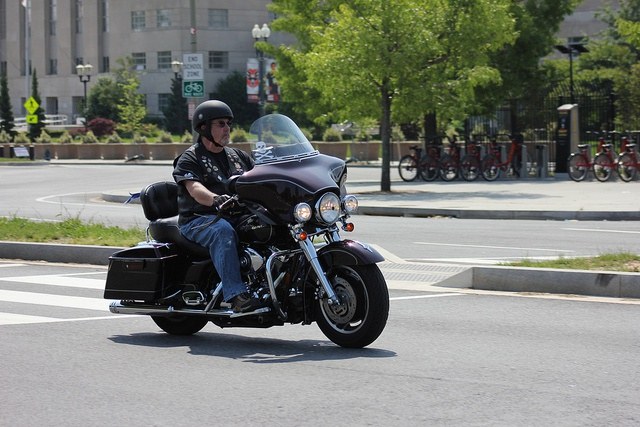Describe the objects in this image and their specific colors. I can see motorcycle in black, gray, and darkgray tones, people in black, gray, navy, and darkblue tones, bicycle in black, gray, maroon, and darkblue tones, bicycle in black, gray, maroon, and darkgray tones, and bicycle in black, gray, and maroon tones in this image. 